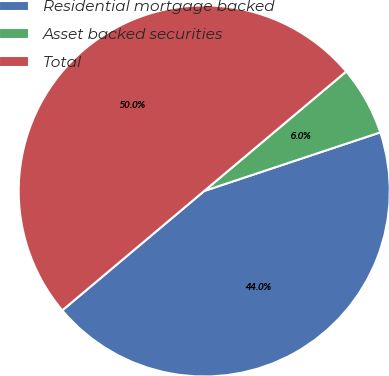Convert chart. <chart><loc_0><loc_0><loc_500><loc_500><pie_chart><fcel>Residential mortgage backed<fcel>Asset backed securities<fcel>Total<nl><fcel>43.98%<fcel>6.02%<fcel>50.0%<nl></chart> 